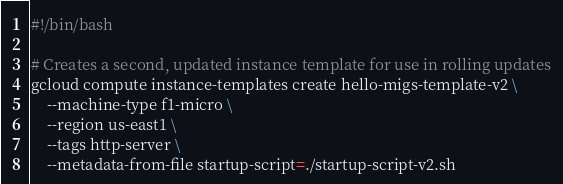<code> <loc_0><loc_0><loc_500><loc_500><_Bash_>#!/bin/bash

# Creates a second, updated instance template for use in rolling updates
gcloud compute instance-templates create hello-migs-template-v2 \
    --machine-type f1-micro \
    --region us-east1 \
    --tags http-server \
    --metadata-from-file startup-script=./startup-script-v2.sh
</code> 